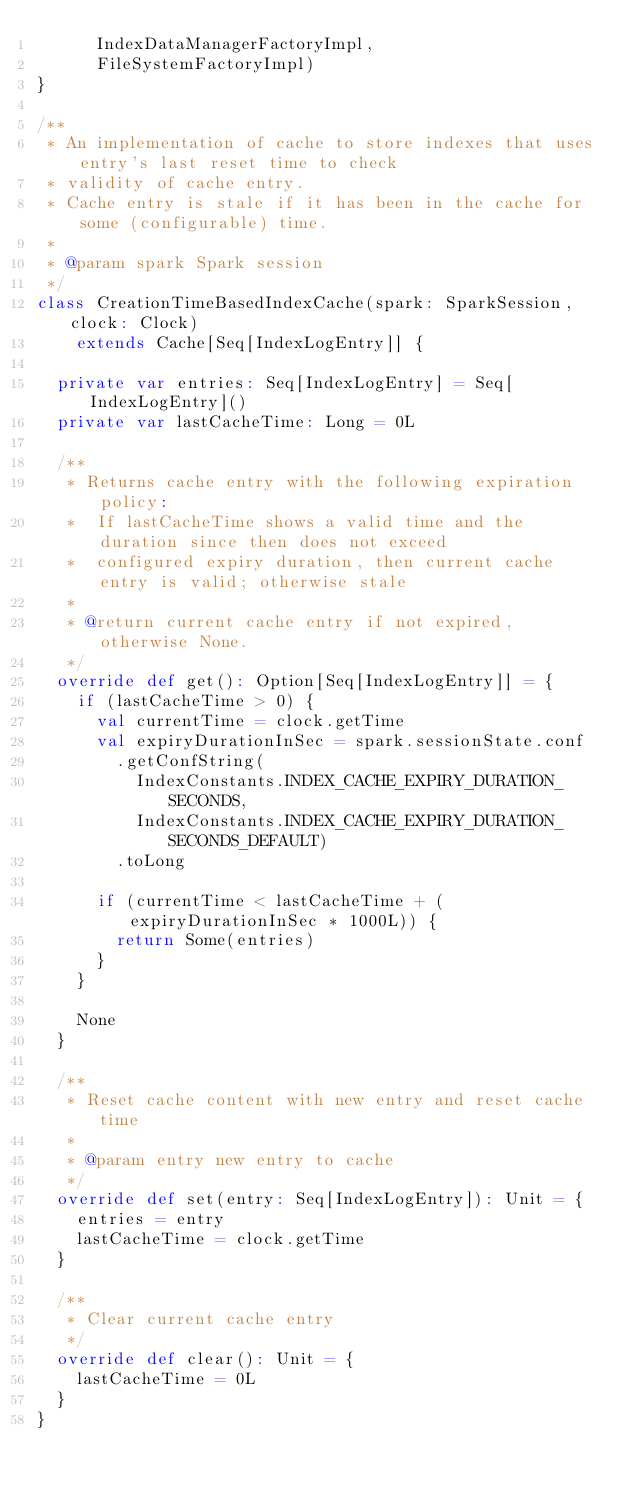Convert code to text. <code><loc_0><loc_0><loc_500><loc_500><_Scala_>      IndexDataManagerFactoryImpl,
      FileSystemFactoryImpl)
}

/**
 * An implementation of cache to store indexes that uses entry's last reset time to check
 * validity of cache entry.
 * Cache entry is stale if it has been in the cache for some (configurable) time.
 *
 * @param spark Spark session
 */
class CreationTimeBasedIndexCache(spark: SparkSession, clock: Clock)
    extends Cache[Seq[IndexLogEntry]] {

  private var entries: Seq[IndexLogEntry] = Seq[IndexLogEntry]()
  private var lastCacheTime: Long = 0L

  /**
   * Returns cache entry with the following expiration policy:
   *  If lastCacheTime shows a valid time and the duration since then does not exceed
   *  configured expiry duration, then current cache entry is valid; otherwise stale
   *
   * @return current cache entry if not expired, otherwise None.
   */
  override def get(): Option[Seq[IndexLogEntry]] = {
    if (lastCacheTime > 0) {
      val currentTime = clock.getTime
      val expiryDurationInSec = spark.sessionState.conf
        .getConfString(
          IndexConstants.INDEX_CACHE_EXPIRY_DURATION_SECONDS,
          IndexConstants.INDEX_CACHE_EXPIRY_DURATION_SECONDS_DEFAULT)
        .toLong

      if (currentTime < lastCacheTime + (expiryDurationInSec * 1000L)) {
        return Some(entries)
      }
    }

    None
  }

  /**
   * Reset cache content with new entry and reset cache time
   *
   * @param entry new entry to cache
   */
  override def set(entry: Seq[IndexLogEntry]): Unit = {
    entries = entry
    lastCacheTime = clock.getTime
  }

  /**
   * Clear current cache entry
   */
  override def clear(): Unit = {
    lastCacheTime = 0L
  }
}
</code> 